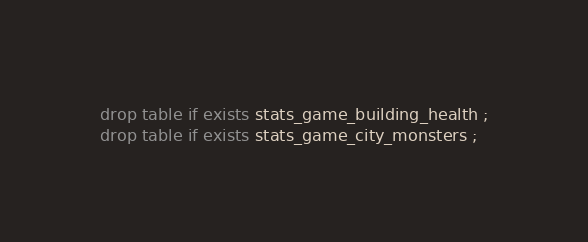<code> <loc_0><loc_0><loc_500><loc_500><_SQL_>
drop table if exists stats_game_building_health ;
drop table if exists stats_game_city_monsters ;
</code> 